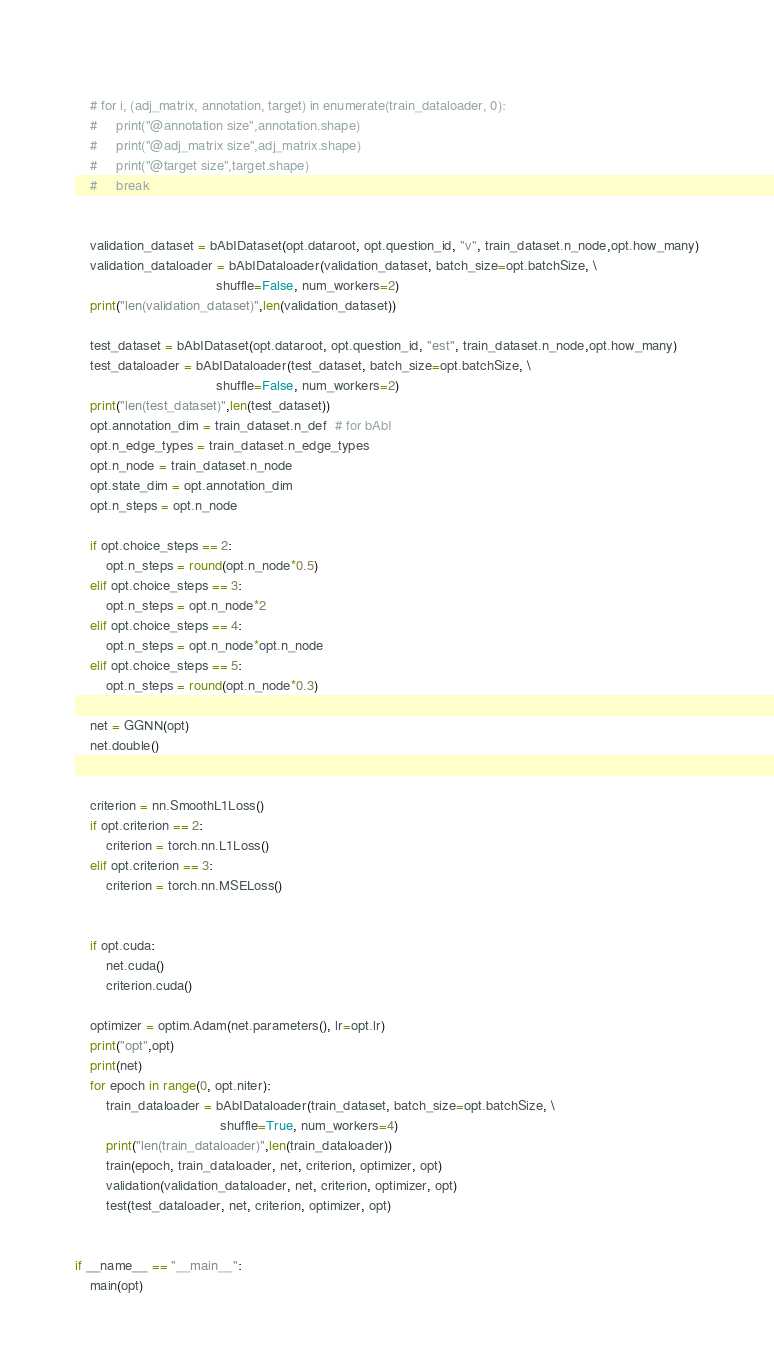<code> <loc_0><loc_0><loc_500><loc_500><_Python_>    
    # for i, (adj_matrix, annotation, target) in enumerate(train_dataloader, 0):
    #     print("@annotation size",annotation.shape)
    #     print("@adj_matrix size",adj_matrix.shape)
    #     print("@target size",target.shape)
    #     break
    

    validation_dataset = bAbIDataset(opt.dataroot, opt.question_id, "v", train_dataset.n_node,opt.how_many)
    validation_dataloader = bAbIDataloader(validation_dataset, batch_size=opt.batchSize, \
                                     shuffle=False, num_workers=2)
    print("len(validation_dataset)",len(validation_dataset))

    test_dataset = bAbIDataset(opt.dataroot, opt.question_id, "est", train_dataset.n_node,opt.how_many)
    test_dataloader = bAbIDataloader(test_dataset, batch_size=opt.batchSize, \
                                     shuffle=False, num_workers=2)
    print("len(test_dataset)",len(test_dataset))
    opt.annotation_dim = train_dataset.n_def  # for bAbI
    opt.n_edge_types = train_dataset.n_edge_types
    opt.n_node = train_dataset.n_node
    opt.state_dim = opt.annotation_dim
    opt.n_steps = opt.n_node
       
    if opt.choice_steps == 2:
        opt.n_steps = round(opt.n_node*0.5)
    elif opt.choice_steps == 3:
        opt.n_steps = opt.n_node*2
    elif opt.choice_steps == 4:
        opt.n_steps = opt.n_node*opt.n_node
    elif opt.choice_steps == 5:
        opt.n_steps = round(opt.n_node*0.3)

    net = GGNN(opt)
    net.double()
    
    
    criterion = nn.SmoothL1Loss()
    if opt.criterion == 2:
        criterion = torch.nn.L1Loss()
    elif opt.criterion == 3:
        criterion = torch.nn.MSELoss()
        

    if opt.cuda:
        net.cuda()
        criterion.cuda()

    optimizer = optim.Adam(net.parameters(), lr=opt.lr)
    print("opt",opt)
    print(net)
    for epoch in range(0, opt.niter):
        train_dataloader = bAbIDataloader(train_dataset, batch_size=opt.batchSize, \
                                      shuffle=True, num_workers=4)
        print("len(train_dataloader)",len(train_dataloader))
        train(epoch, train_dataloader, net, criterion, optimizer, opt)
        validation(validation_dataloader, net, criterion, optimizer, opt)
        test(test_dataloader, net, criterion, optimizer, opt)


if __name__ == "__main__":
    main(opt)

</code> 